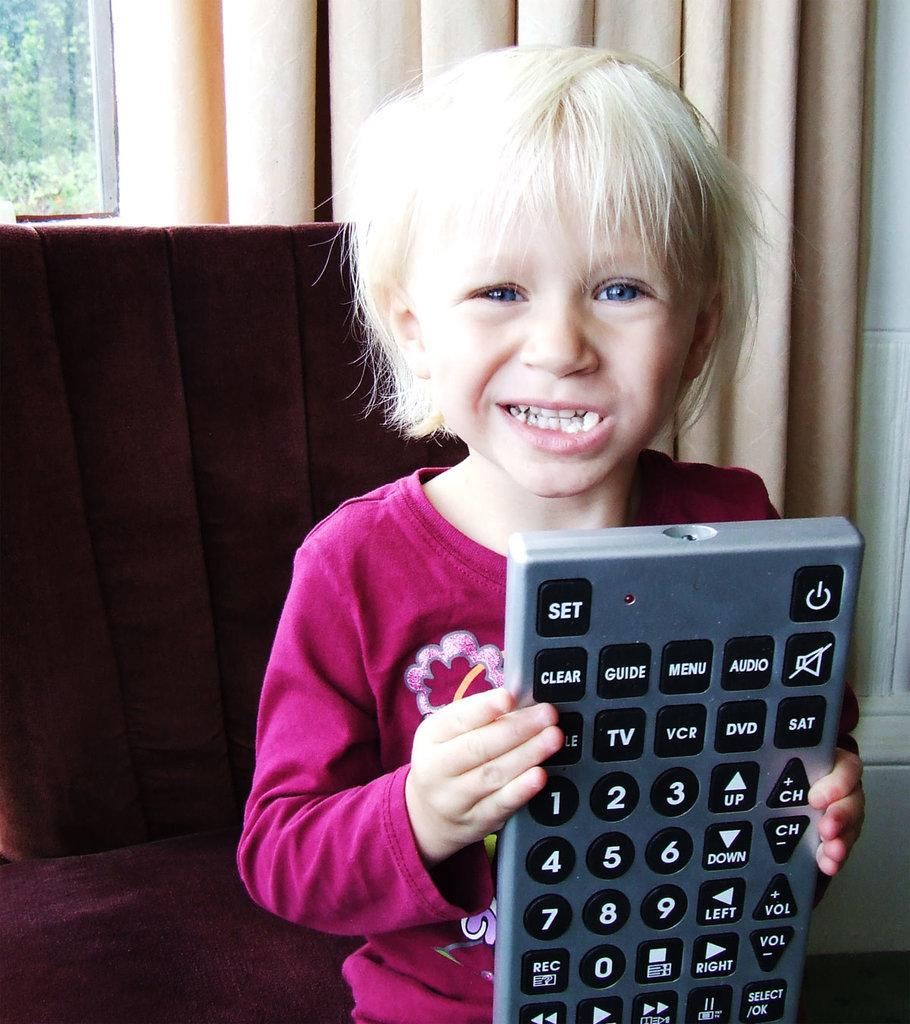What type of furniture is in the image? There is a sofa in the image. What object is used for controlling electronic devices? There is a remote in the image. What is the boy doing in the image? The boy is standing in the image. What architectural feature is present in the image? There is a window in the image. What is the background of the image made of? There is a wall in the image. What can be seen outside the window? Trees are visible outside the window. What type of plough is being used by the boy in the image? There is no plough present in the image; the boy is standing. What type of suit is the sofa wearing in the image? The sofa is an inanimate object and does not wear clothing, such as a suit. 